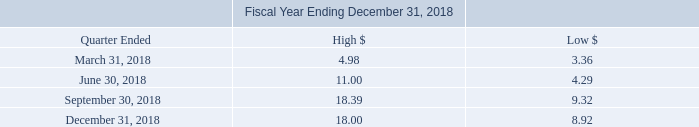Market Information
Our common stock is traded under the symbol “OPRX” on the Nasdaq Capital Market. Only a limited market exists for our securities. There is no assurance that a regular trading market will develop, or if developed, that it will be sustained. Therefore, a shareholder may be unable to resell his securities in our company.
The following tables set forth the range of high and low bid information for our common stock for the each of the periods indicated. These quotations reflect inter-dealer prices, without retail mark-up, mark-down or commission and may not necessarily represent actual transactions.
On March 24, 2020, the last sales price per share of our common stock was $7.93
What is the Company’s trading symbol?  Oprx. What does the table show us? The range of high and low bid information for our common stock for the each of the periods indicated. What was the last sales price per share of the Company’s common stock on March 24, 2020? $7.93. What is the average of high bids throughout 2018?  (4.98+11.00+18.39+18.00)/4 
Answer: 13.09. Which quarter had the greatest low bid on the Company’s common stock? 9.32>8.92>4.29>3.36
Answer: september 30, 2018. What is the ratio of the last sales price of the Company’s common stock on March 24, 2020, to the low bid on September 30, 2018? 7.93/9.32 
Answer: 0.85. 